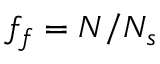<formula> <loc_0><loc_0><loc_500><loc_500>f _ { f } = N / N _ { s }</formula> 